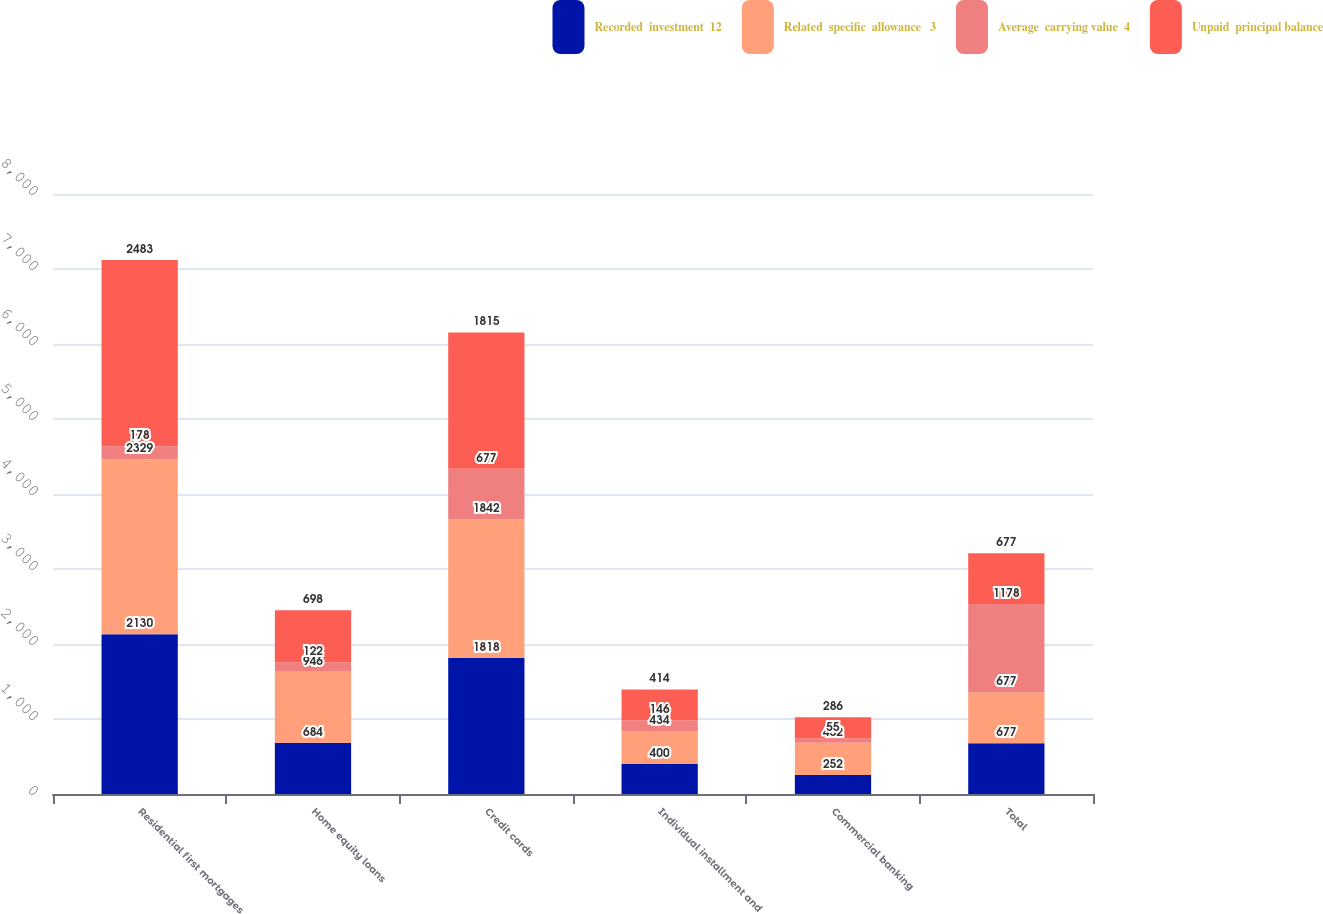Convert chart. <chart><loc_0><loc_0><loc_500><loc_500><stacked_bar_chart><ecel><fcel>Residential first mortgages<fcel>Home equity loans<fcel>Credit cards<fcel>Individual installment and<fcel>Commercial banking<fcel>Total<nl><fcel>Recorded  investment  12<fcel>2130<fcel>684<fcel>1818<fcel>400<fcel>252<fcel>677<nl><fcel>Related  specific  allowance   3<fcel>2329<fcel>946<fcel>1842<fcel>434<fcel>432<fcel>677<nl><fcel>Average  carrying value  4<fcel>178<fcel>122<fcel>677<fcel>146<fcel>55<fcel>1178<nl><fcel>Unpaid  principal balance<fcel>2483<fcel>698<fcel>1815<fcel>414<fcel>286<fcel>677<nl></chart> 